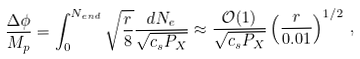<formula> <loc_0><loc_0><loc_500><loc_500>\frac { \Delta \phi } { M _ { p } } = \int _ { 0 } ^ { N _ { e n d } } \sqrt { \frac { r } { 8 } } \frac { d N _ { e } } { \sqrt { c _ { s } P _ { X } } } \approx \frac { { \mathcal { O } } ( 1 ) } { \sqrt { c _ { s } P _ { X } } } \left ( \frac { r } { 0 . 0 1 } \right ) ^ { 1 / 2 } \, ,</formula> 